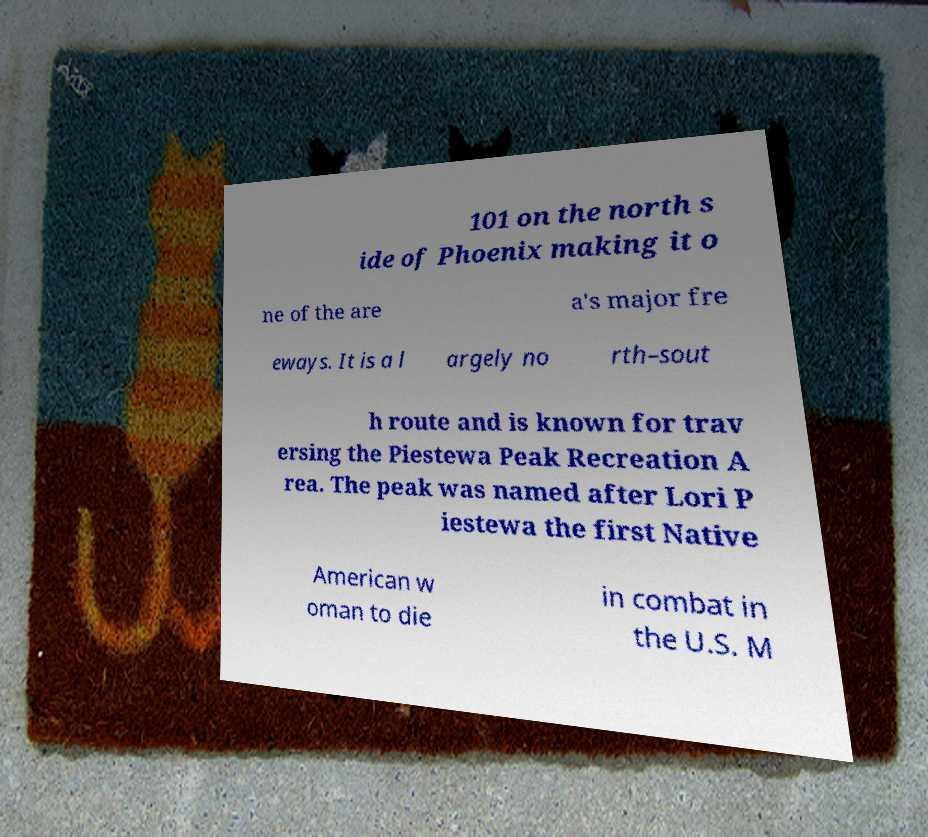Can you accurately transcribe the text from the provided image for me? 101 on the north s ide of Phoenix making it o ne of the are a's major fre eways. It is a l argely no rth–sout h route and is known for trav ersing the Piestewa Peak Recreation A rea. The peak was named after Lori P iestewa the first Native American w oman to die in combat in the U.S. M 